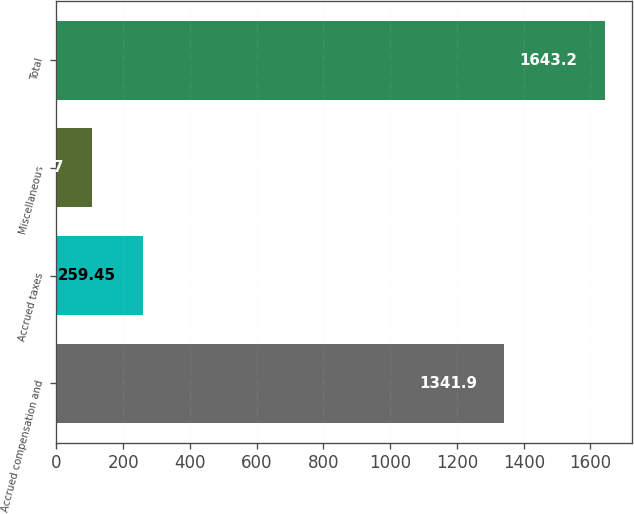<chart> <loc_0><loc_0><loc_500><loc_500><bar_chart><fcel>Accrued compensation and<fcel>Accrued taxes<fcel>Miscellaneous<fcel>Total<nl><fcel>1341.9<fcel>259.45<fcel>105.7<fcel>1643.2<nl></chart> 